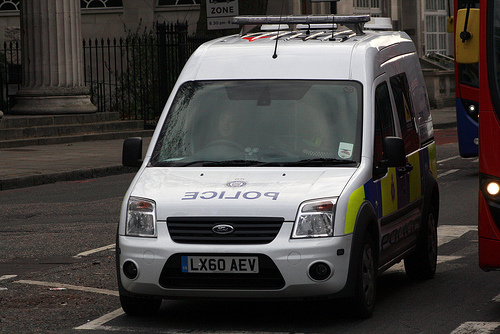<image>
Can you confirm if the bus is to the left of the car? No. The bus is not to the left of the car. From this viewpoint, they have a different horizontal relationship. 